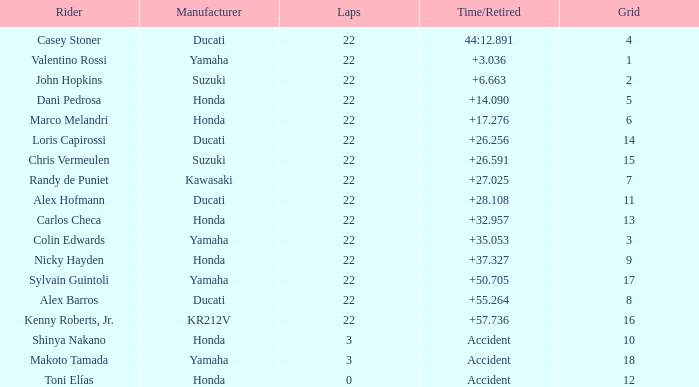What was the average amount of laps for competitors with a grid that was more than 11 and a Time/Retired of +28.108? None. I'm looking to parse the entire table for insights. Could you assist me with that? {'header': ['Rider', 'Manufacturer', 'Laps', 'Time/Retired', 'Grid'], 'rows': [['Casey Stoner', 'Ducati', '22', '44:12.891', '4'], ['Valentino Rossi', 'Yamaha', '22', '+3.036', '1'], ['John Hopkins', 'Suzuki', '22', '+6.663', '2'], ['Dani Pedrosa', 'Honda', '22', '+14.090', '5'], ['Marco Melandri', 'Honda', '22', '+17.276', '6'], ['Loris Capirossi', 'Ducati', '22', '+26.256', '14'], ['Chris Vermeulen', 'Suzuki', '22', '+26.591', '15'], ['Randy de Puniet', 'Kawasaki', '22', '+27.025', '7'], ['Alex Hofmann', 'Ducati', '22', '+28.108', '11'], ['Carlos Checa', 'Honda', '22', '+32.957', '13'], ['Colin Edwards', 'Yamaha', '22', '+35.053', '3'], ['Nicky Hayden', 'Honda', '22', '+37.327', '9'], ['Sylvain Guintoli', 'Yamaha', '22', '+50.705', '17'], ['Alex Barros', 'Ducati', '22', '+55.264', '8'], ['Kenny Roberts, Jr.', 'KR212V', '22', '+57.736', '16'], ['Shinya Nakano', 'Honda', '3', 'Accident', '10'], ['Makoto Tamada', 'Yamaha', '3', 'Accident', '18'], ['Toni Elías', 'Honda', '0', 'Accident', '12']]} 